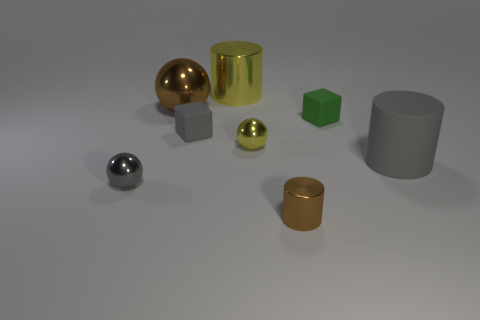There is a gray object that is the same shape as the tiny brown metallic thing; what is its material?
Offer a terse response. Rubber. There is a ball that is both on the left side of the yellow metallic ball and behind the small gray sphere; how big is it?
Provide a short and direct response. Large. Are there more large brown balls that are on the right side of the small cylinder than yellow cylinders that are in front of the large brown metallic ball?
Make the answer very short. No. What is the color of the other small thing that is the same shape as the tiny gray rubber thing?
Your response must be concise. Green. Do the shiny ball that is in front of the big gray cylinder and the rubber cylinder have the same color?
Provide a succinct answer. Yes. What number of gray matte things are there?
Your response must be concise. 2. Is the material of the large object that is in front of the tiny green cube the same as the large yellow object?
Offer a very short reply. No. Are there any other things that have the same material as the brown cylinder?
Provide a succinct answer. Yes. There is a gray thing that is in front of the cylinder to the right of the small metallic cylinder; how many small objects are behind it?
Your answer should be very brief. 3. What size is the gray metallic object?
Keep it short and to the point. Small. 